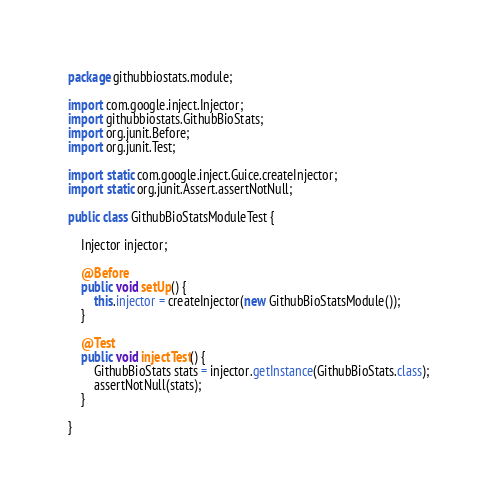Convert code to text. <code><loc_0><loc_0><loc_500><loc_500><_Java_>package githubbiostats.module;

import com.google.inject.Injector;
import githubbiostats.GithubBioStats;
import org.junit.Before;
import org.junit.Test;

import static com.google.inject.Guice.createInjector;
import static org.junit.Assert.assertNotNull;

public class GithubBioStatsModuleTest {

    Injector injector;

    @Before
    public void setUp() {
        this.injector = createInjector(new GithubBioStatsModule());
    }

    @Test
    public void injectTest() {
        GithubBioStats stats = injector.getInstance(GithubBioStats.class);
        assertNotNull(stats);
    }

}
</code> 